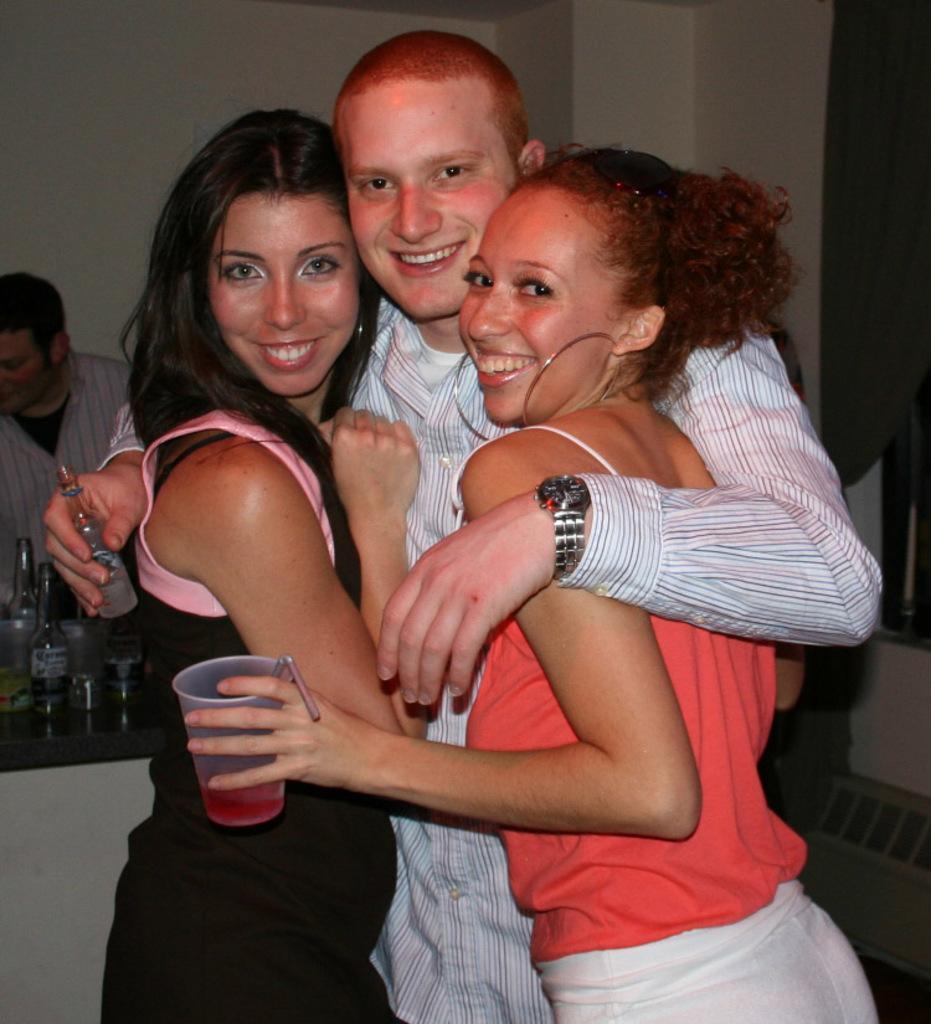Could you give a brief overview of what you see in this image? In this image we can see four persons, among them, two are holding the objects, also we can see a table with some bottles on it and in the background, we can see the wall. 